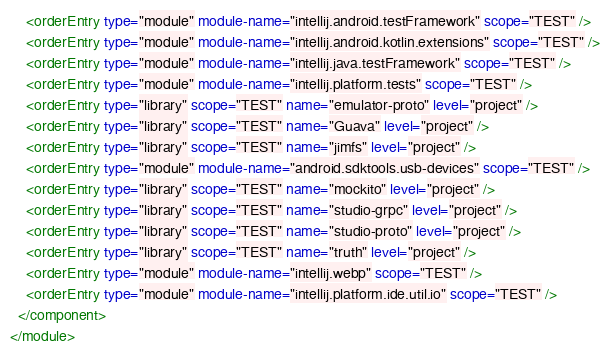<code> <loc_0><loc_0><loc_500><loc_500><_XML_>    <orderEntry type="module" module-name="intellij.android.testFramework" scope="TEST" />
    <orderEntry type="module" module-name="intellij.android.kotlin.extensions" scope="TEST" />
    <orderEntry type="module" module-name="intellij.java.testFramework" scope="TEST" />
    <orderEntry type="module" module-name="intellij.platform.tests" scope="TEST" />
    <orderEntry type="library" scope="TEST" name="emulator-proto" level="project" />
    <orderEntry type="library" scope="TEST" name="Guava" level="project" />
    <orderEntry type="library" scope="TEST" name="jimfs" level="project" />
    <orderEntry type="module" module-name="android.sdktools.usb-devices" scope="TEST" />
    <orderEntry type="library" scope="TEST" name="mockito" level="project" />
    <orderEntry type="library" scope="TEST" name="studio-grpc" level="project" />
    <orderEntry type="library" scope="TEST" name="studio-proto" level="project" />
    <orderEntry type="library" scope="TEST" name="truth" level="project" />
    <orderEntry type="module" module-name="intellij.webp" scope="TEST" />
    <orderEntry type="module" module-name="intellij.platform.ide.util.io" scope="TEST" />
  </component>
</module></code> 